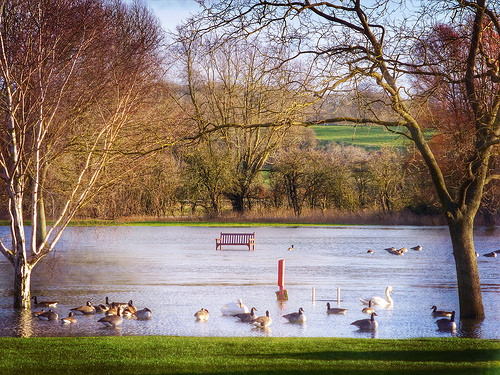<image>
Can you confirm if the ducks is on the grass? No. The ducks is not positioned on the grass. They may be near each other, but the ducks is not supported by or resting on top of the grass. 